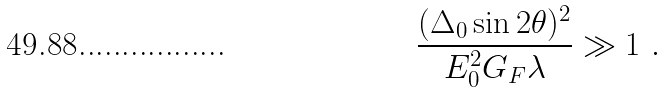<formula> <loc_0><loc_0><loc_500><loc_500>\frac { ( \Delta _ { 0 } \sin 2 \theta ) ^ { 2 } } { E _ { 0 } ^ { 2 } G _ { F } \lambda } \gg 1 \ .</formula> 